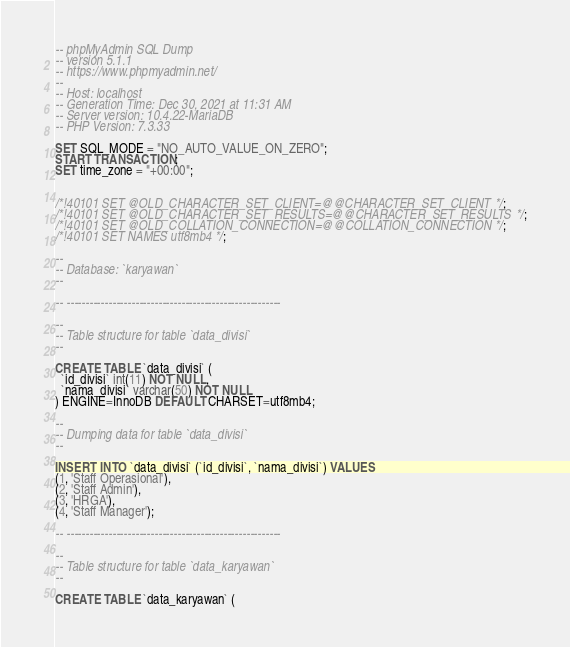<code> <loc_0><loc_0><loc_500><loc_500><_SQL_>-- phpMyAdmin SQL Dump
-- version 5.1.1
-- https://www.phpmyadmin.net/
--
-- Host: localhost
-- Generation Time: Dec 30, 2021 at 11:31 AM
-- Server version: 10.4.22-MariaDB
-- PHP Version: 7.3.33

SET SQL_MODE = "NO_AUTO_VALUE_ON_ZERO";
START TRANSACTION;
SET time_zone = "+00:00";


/*!40101 SET @OLD_CHARACTER_SET_CLIENT=@@CHARACTER_SET_CLIENT */;
/*!40101 SET @OLD_CHARACTER_SET_RESULTS=@@CHARACTER_SET_RESULTS */;
/*!40101 SET @OLD_COLLATION_CONNECTION=@@COLLATION_CONNECTION */;
/*!40101 SET NAMES utf8mb4 */;

--
-- Database: `karyawan`
--

-- --------------------------------------------------------

--
-- Table structure for table `data_divisi`
--

CREATE TABLE `data_divisi` (
  `id_divisi` int(11) NOT NULL,
  `nama_divisi` varchar(50) NOT NULL
) ENGINE=InnoDB DEFAULT CHARSET=utf8mb4;

--
-- Dumping data for table `data_divisi`
--

INSERT INTO `data_divisi` (`id_divisi`, `nama_divisi`) VALUES
(1, 'Staff Operasional'),
(2, 'Staff Admin'),
(3, 'HRGA'),
(4, 'Staff Manager');

-- --------------------------------------------------------

--
-- Table structure for table `data_karyawan`
--

CREATE TABLE `data_karyawan` (</code> 